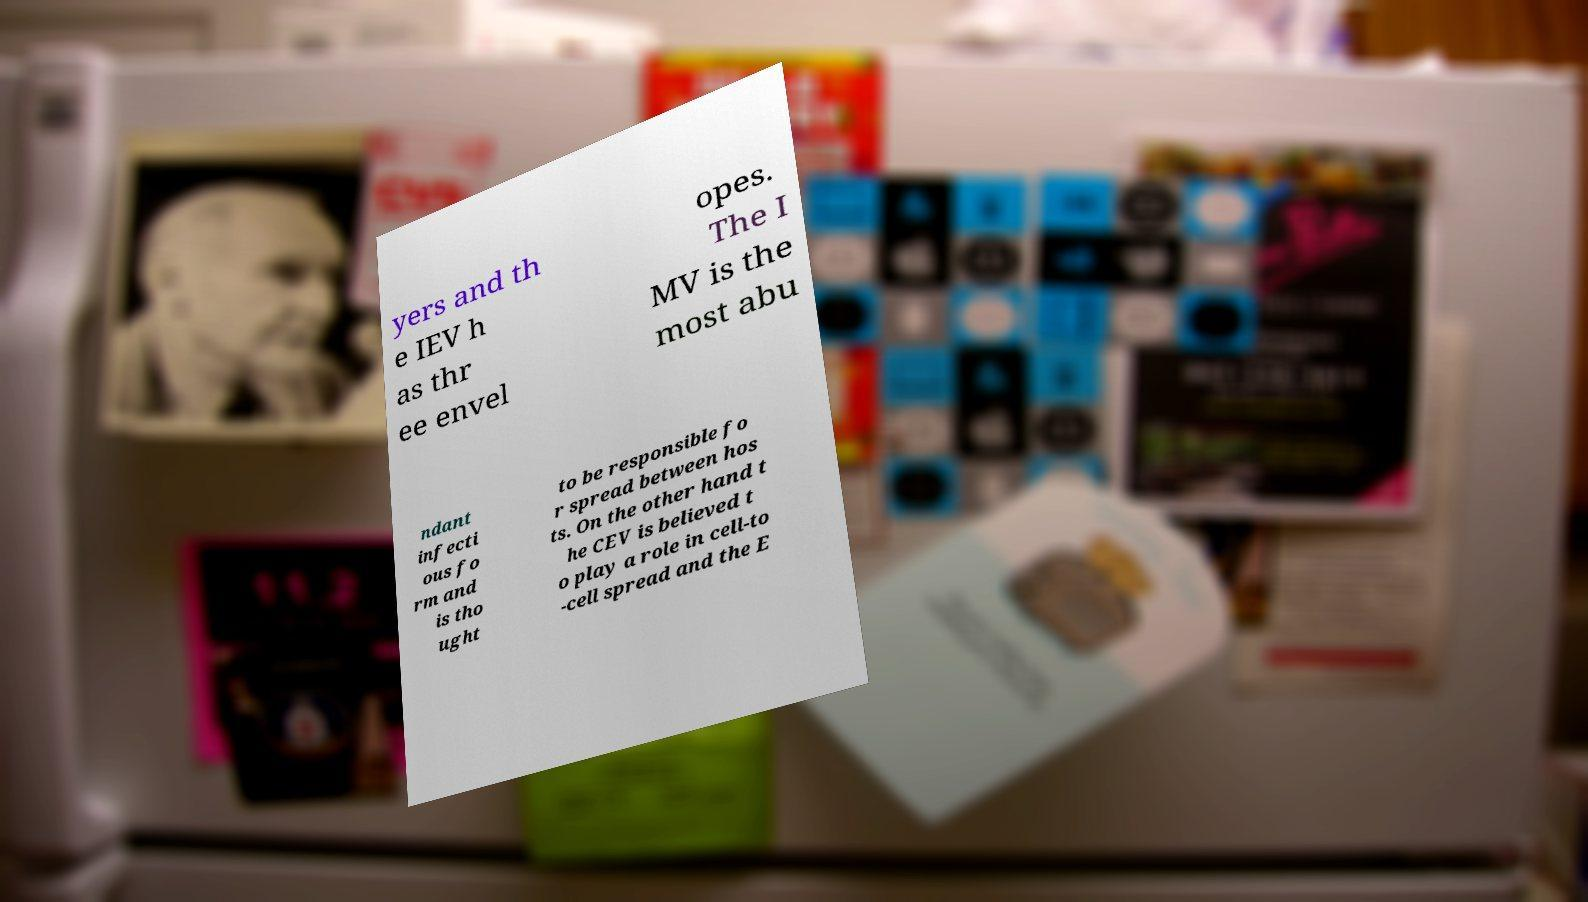Please identify and transcribe the text found in this image. yers and th e IEV h as thr ee envel opes. The I MV is the most abu ndant infecti ous fo rm and is tho ught to be responsible fo r spread between hos ts. On the other hand t he CEV is believed t o play a role in cell-to -cell spread and the E 